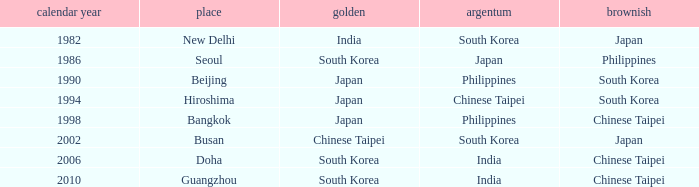How many years has Japan won silver? 1986.0. 